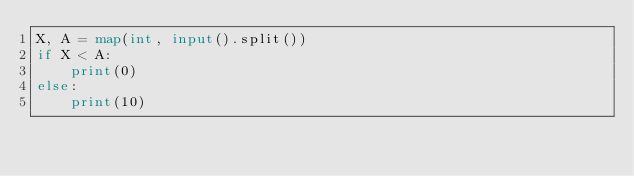Convert code to text. <code><loc_0><loc_0><loc_500><loc_500><_Python_>X, A = map(int, input().split())
if X < A:
    print(0)
else:
    print(10)</code> 